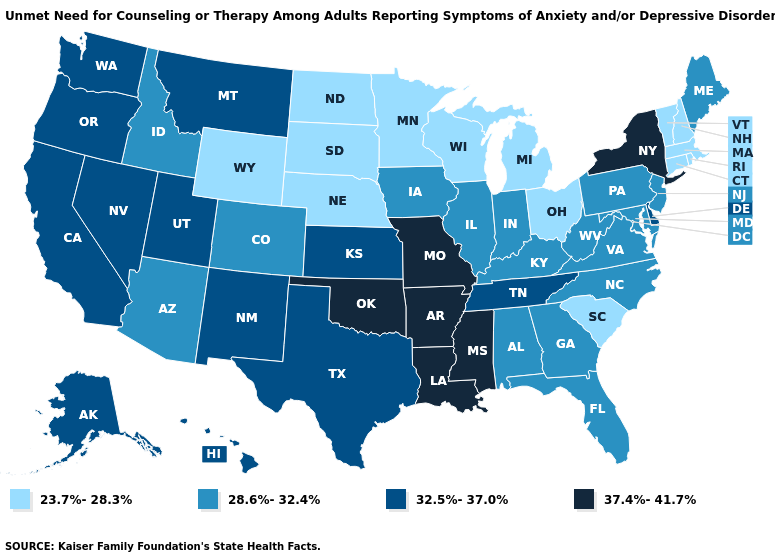Does Kansas have a lower value than Wyoming?
Concise answer only. No. What is the lowest value in the South?
Answer briefly. 23.7%-28.3%. Does Rhode Island have the lowest value in the Northeast?
Quick response, please. Yes. Which states hav the highest value in the South?
Write a very short answer. Arkansas, Louisiana, Mississippi, Oklahoma. Does the first symbol in the legend represent the smallest category?
Quick response, please. Yes. Does Kansas have the same value as Tennessee?
Keep it brief. Yes. Does Georgia have the lowest value in the South?
Concise answer only. No. Is the legend a continuous bar?
Quick response, please. No. Name the states that have a value in the range 28.6%-32.4%?
Give a very brief answer. Alabama, Arizona, Colorado, Florida, Georgia, Idaho, Illinois, Indiana, Iowa, Kentucky, Maine, Maryland, New Jersey, North Carolina, Pennsylvania, Virginia, West Virginia. What is the value of Nebraska?
Be succinct. 23.7%-28.3%. What is the value of Texas?
Quick response, please. 32.5%-37.0%. Name the states that have a value in the range 32.5%-37.0%?
Quick response, please. Alaska, California, Delaware, Hawaii, Kansas, Montana, Nevada, New Mexico, Oregon, Tennessee, Texas, Utah, Washington. Among the states that border Kansas , which have the lowest value?
Be succinct. Nebraska. What is the lowest value in the USA?
Quick response, please. 23.7%-28.3%. What is the lowest value in states that border Arizona?
Concise answer only. 28.6%-32.4%. 